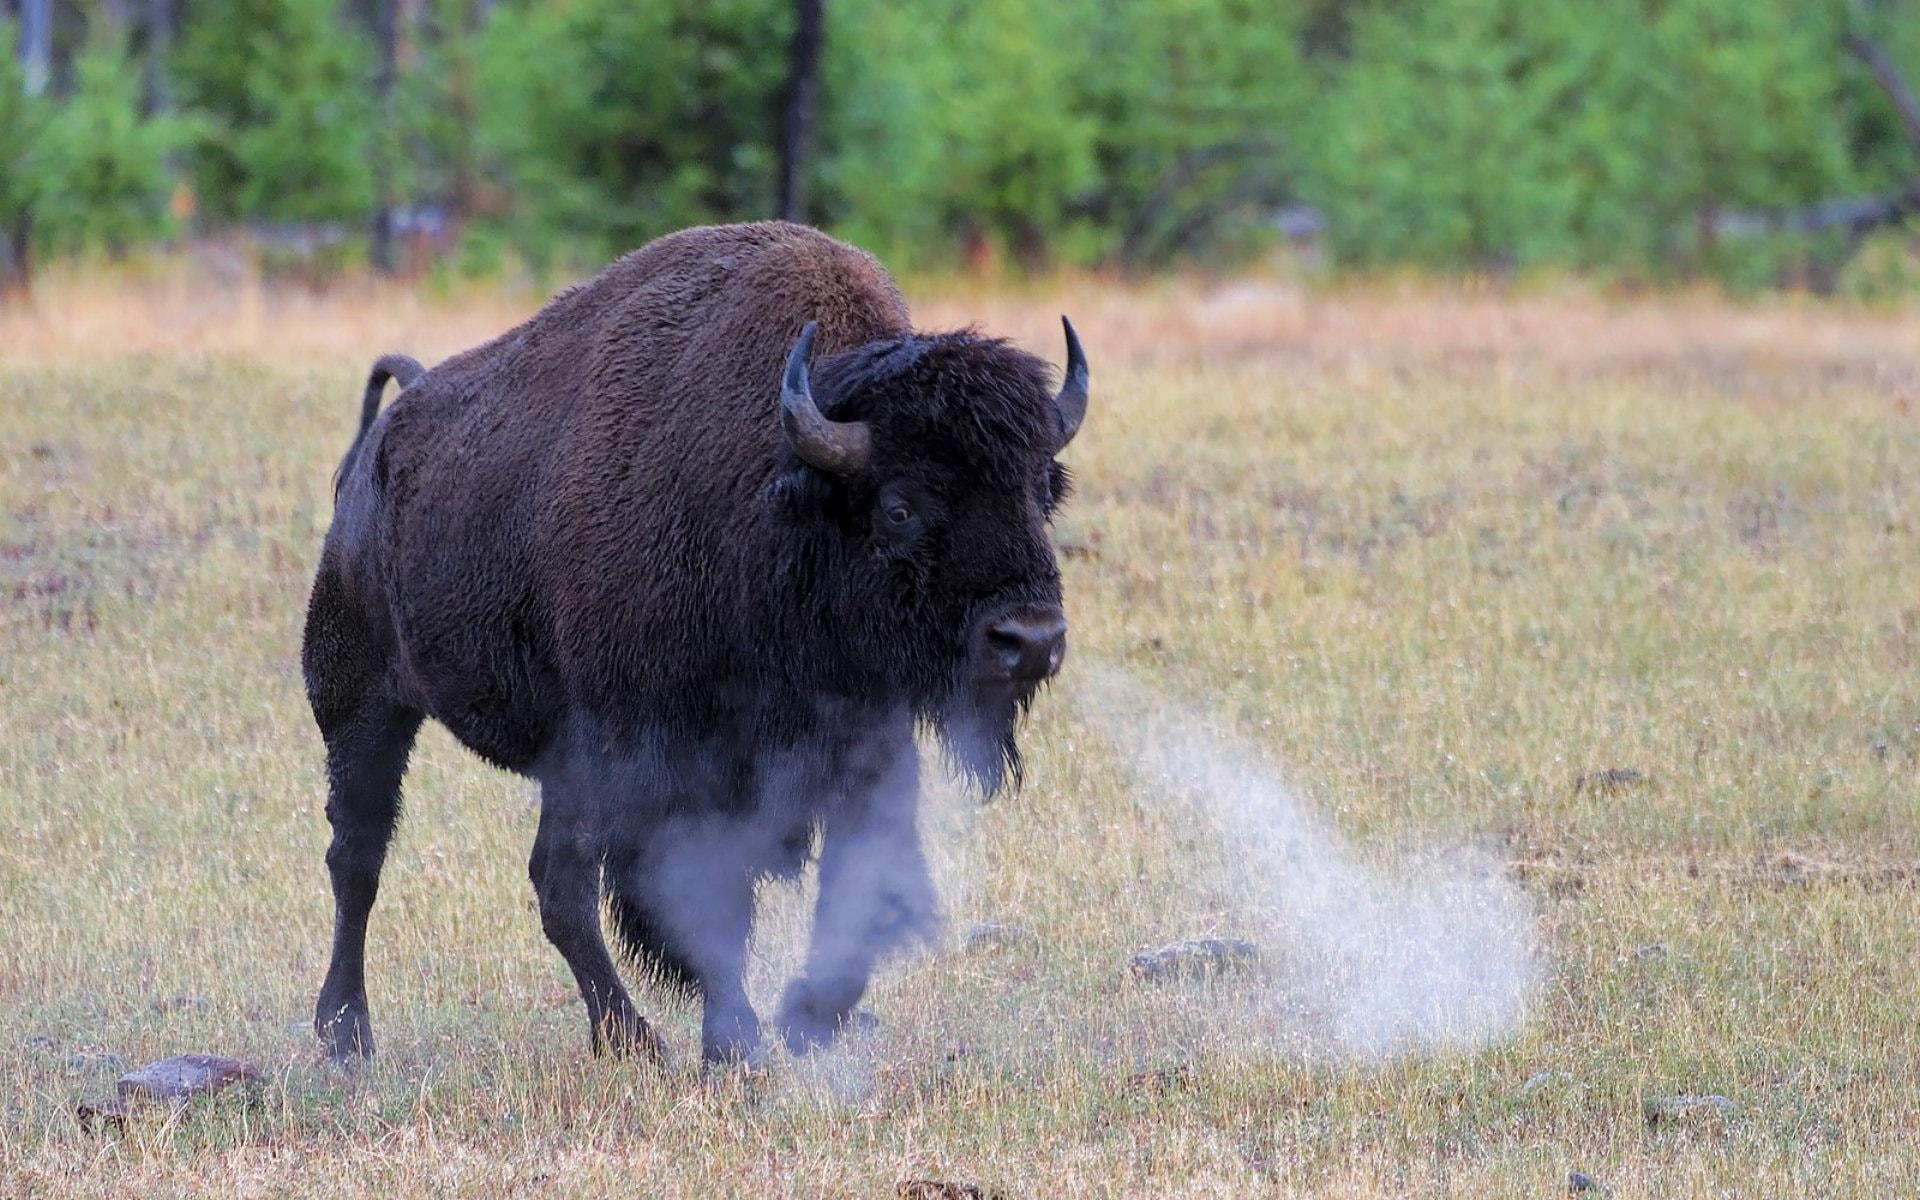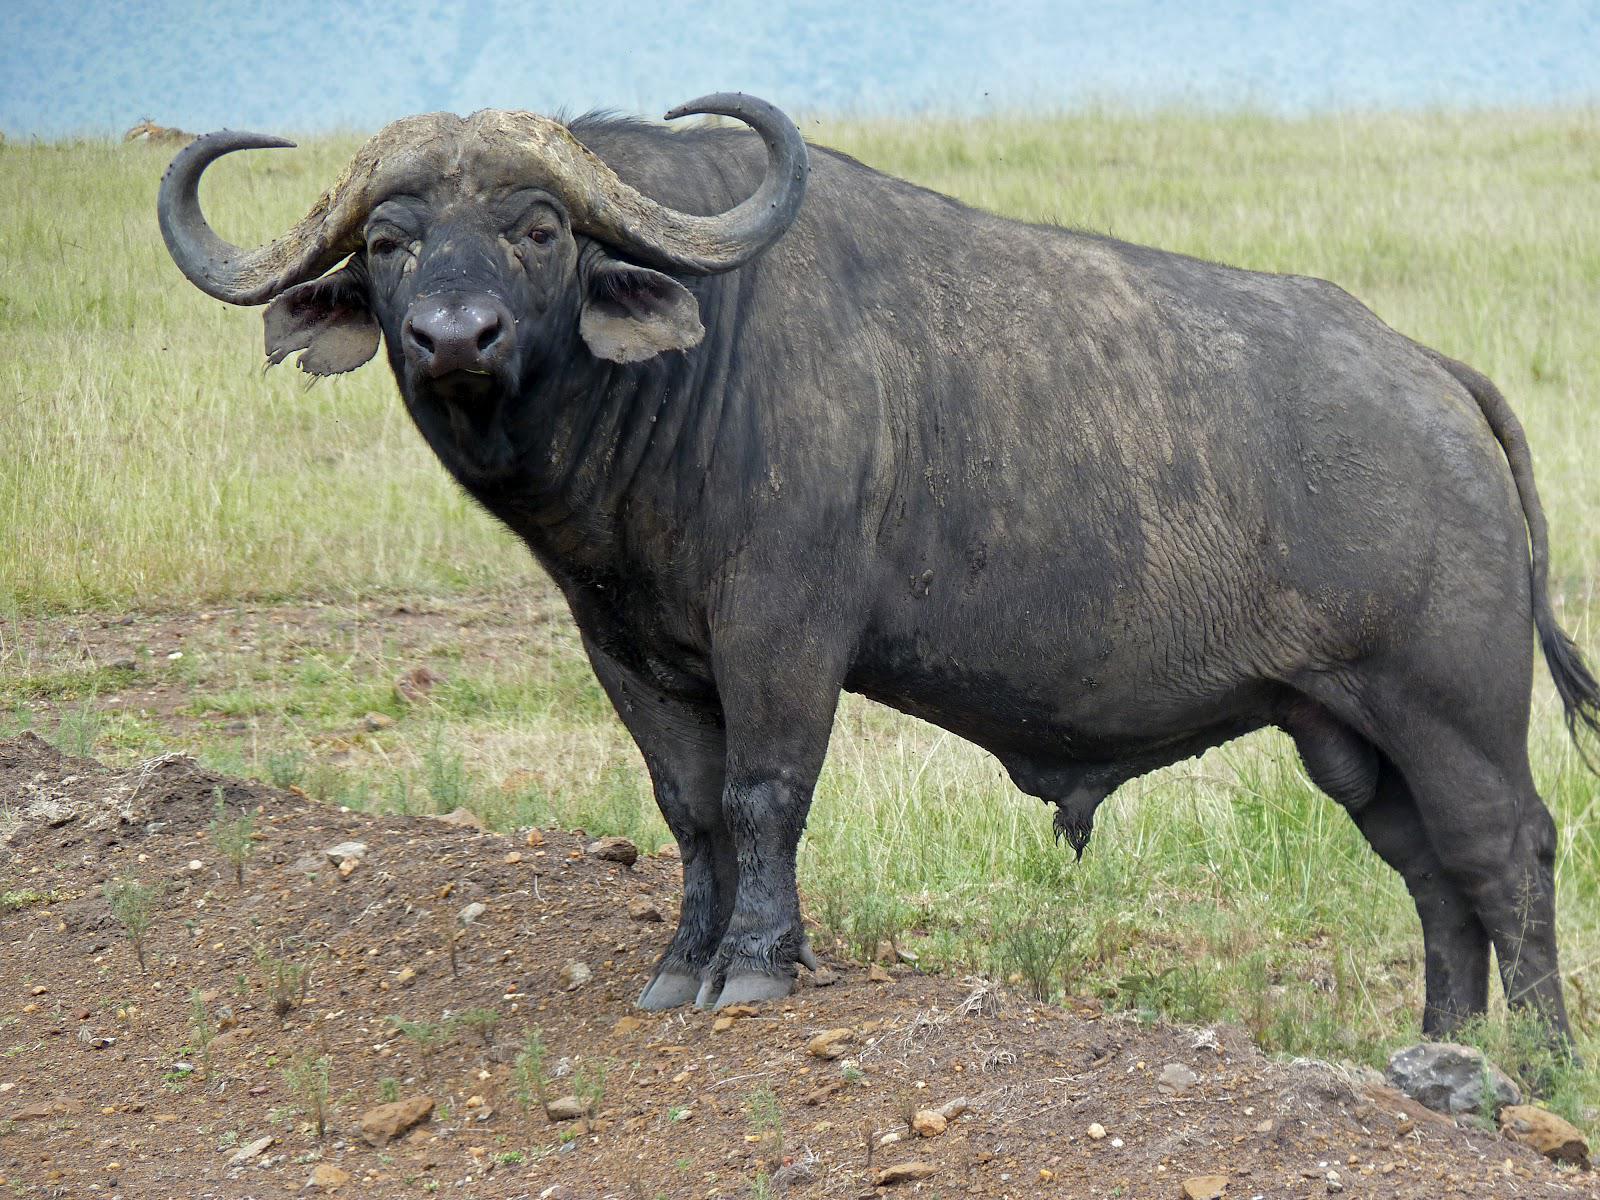The first image is the image on the left, the second image is the image on the right. Evaluate the accuracy of this statement regarding the images: "There are at least two water buffalo's in the right image.". Is it true? Answer yes or no. No. 